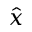<formula> <loc_0><loc_0><loc_500><loc_500>\hat { x }</formula> 